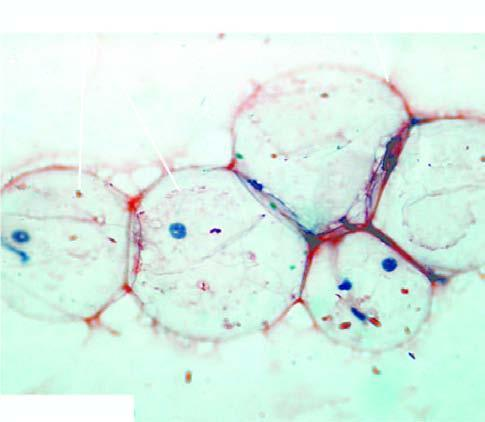what is stained with congo red stain for amyloid?
Answer the question using a single word or phrase. Abdominal fat aspirate 